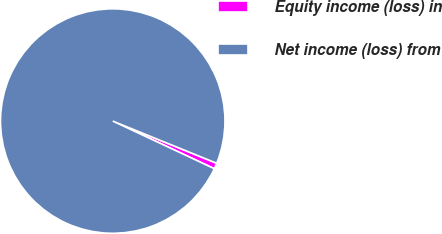Convert chart. <chart><loc_0><loc_0><loc_500><loc_500><pie_chart><fcel>Equity income (loss) in<fcel>Net income (loss) from<nl><fcel>0.84%<fcel>99.16%<nl></chart> 